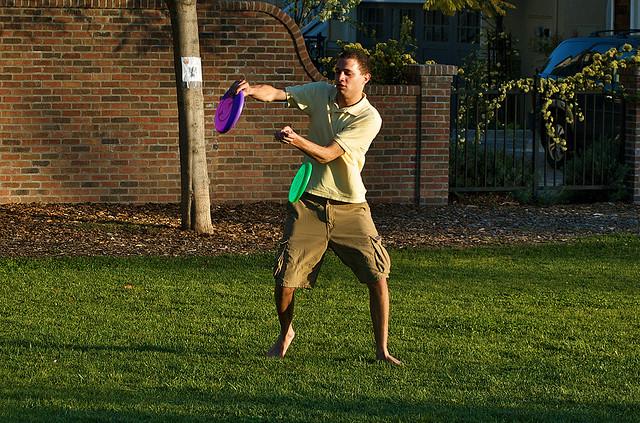What is he holding?
Give a very brief answer. Frisbee. What kind of fence is in the background?
Answer briefly. Iron. Do the man's cargo pockets appear full?
Keep it brief. Yes. What color shirt is this person wearing?
Give a very brief answer. Yellow. What is in the man's right hand?
Short answer required. Frisbee. What sport is being played?
Concise answer only. Frisbee. Is the guy doing a handstand?
Be succinct. No. Which sport is this?
Concise answer only. Frisbee. What is the man holding in hand?
Concise answer only. Frisbee. What type of fence is in the background?
Be succinct. Iron. Is there a shadow?
Keep it brief. Yes. What type of stance is the man in?
Short answer required. Standing. How many people do you see?
Short answer required. 1. Where is this?
Short answer required. Park. Has someone defaced the tree?
Keep it brief. Yes. Do these men look like they've played tennis before?
Be succinct. No. What color is the frisbee?
Keep it brief. Purple. What are those yellow objects in the court?
Short answer required. Flowers. Have you ever had a hair cut like this?
Keep it brief. No. What is he doing?
Be succinct. Playing frisbee. What color is the man's shirt?
Concise answer only. Yellow. Are they at the beach?
Give a very brief answer. No. Is it raining?
Short answer required. No. Does the man have both feet on the ground?
Give a very brief answer. Yes. Is he going to get hurt?
Give a very brief answer. No. How many players are there?
Give a very brief answer. 1. 